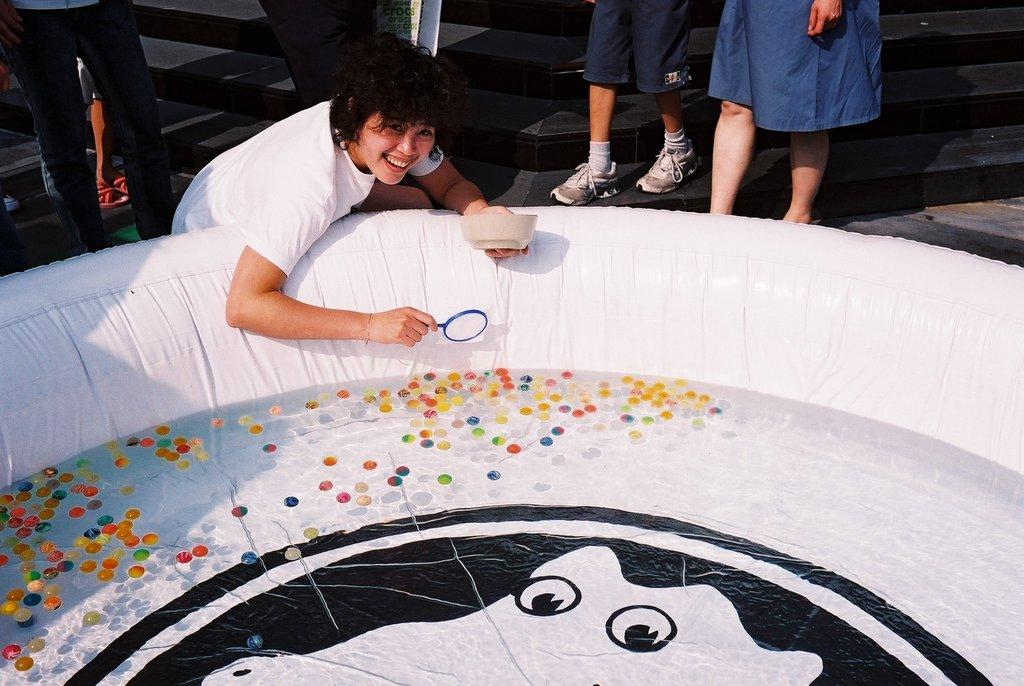Who is the main subject in the image? There is a girl in the image. What is the girl holding in her hands? The girl is holding a bowl and a spoon. What can be seen at the bottom of the image? There is a tub at the bottom of the image. What is inside the tub? There is water and balls in the tub. Can you describe the people in the background of the image? There are people in the background of the image, but their specific actions or features are not mentioned in the provided facts. What type of fang can be seen in the girl's mouth in the image? There is no fang visible in the girl's mouth in the image. Can you tell me how many pails of wine are present in the image? There is no mention of pails or wine in the provided facts, so it cannot be determined from the image. 